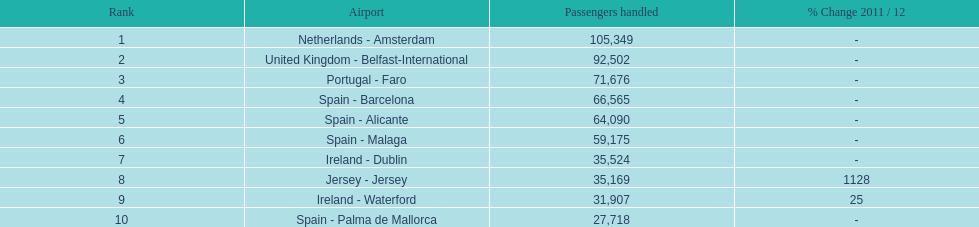Which airport handled a maximum of 30,000 passengers on the top 10 busiest routes to and from london southend airport in 2012? Spain - Palma de Mallorca. 